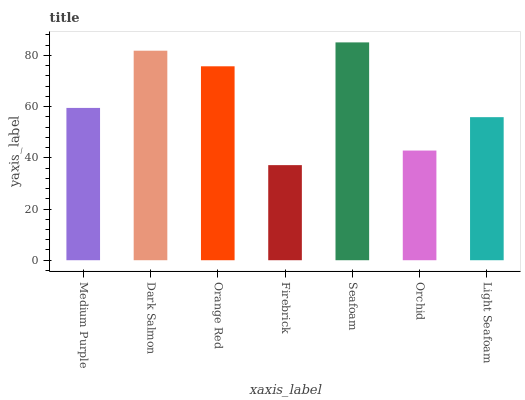Is Dark Salmon the minimum?
Answer yes or no. No. Is Dark Salmon the maximum?
Answer yes or no. No. Is Dark Salmon greater than Medium Purple?
Answer yes or no. Yes. Is Medium Purple less than Dark Salmon?
Answer yes or no. Yes. Is Medium Purple greater than Dark Salmon?
Answer yes or no. No. Is Dark Salmon less than Medium Purple?
Answer yes or no. No. Is Medium Purple the high median?
Answer yes or no. Yes. Is Medium Purple the low median?
Answer yes or no. Yes. Is Seafoam the high median?
Answer yes or no. No. Is Dark Salmon the low median?
Answer yes or no. No. 